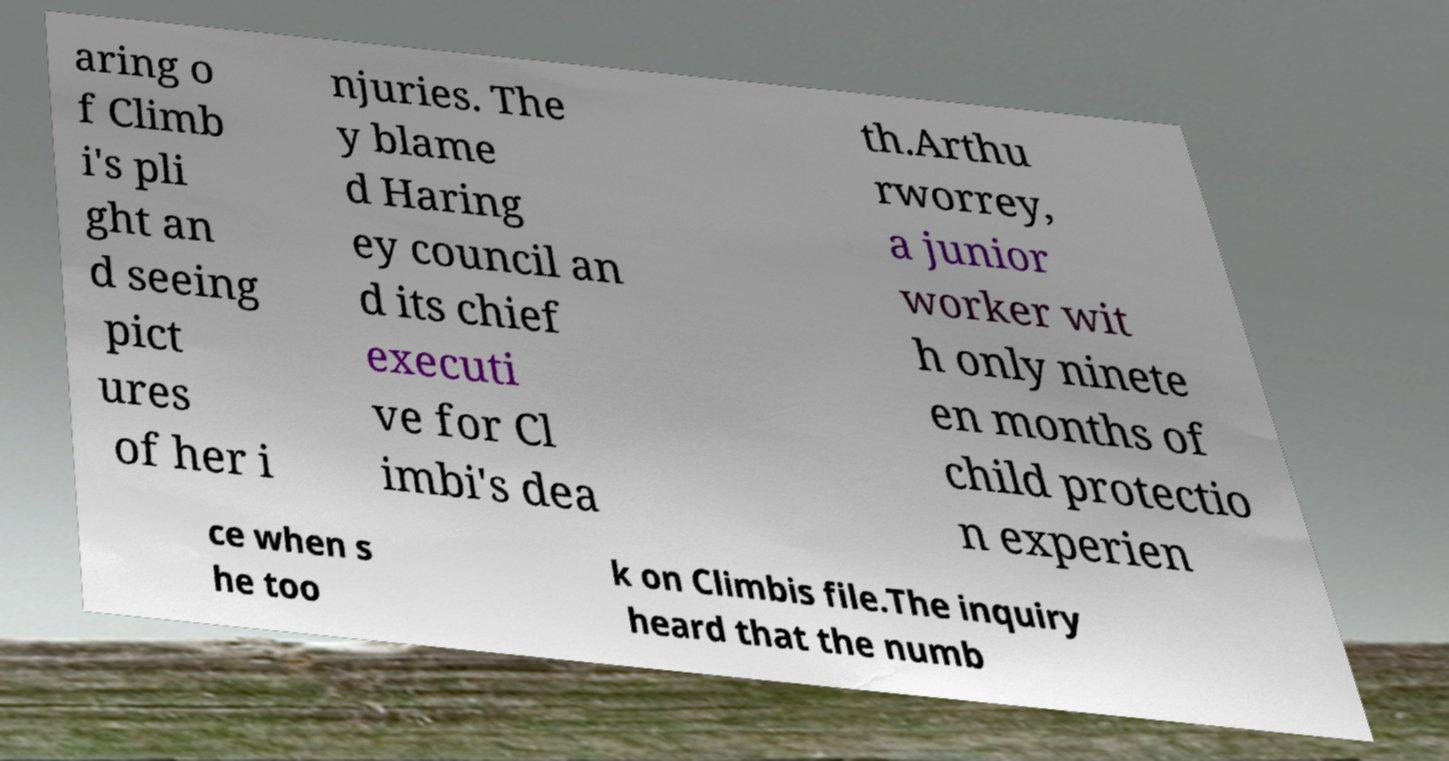Please identify and transcribe the text found in this image. aring o f Climb i's pli ght an d seeing pict ures of her i njuries. The y blame d Haring ey council an d its chief executi ve for Cl imbi's dea th.Arthu rworrey, a junior worker wit h only ninete en months of child protectio n experien ce when s he too k on Climbis file.The inquiry heard that the numb 